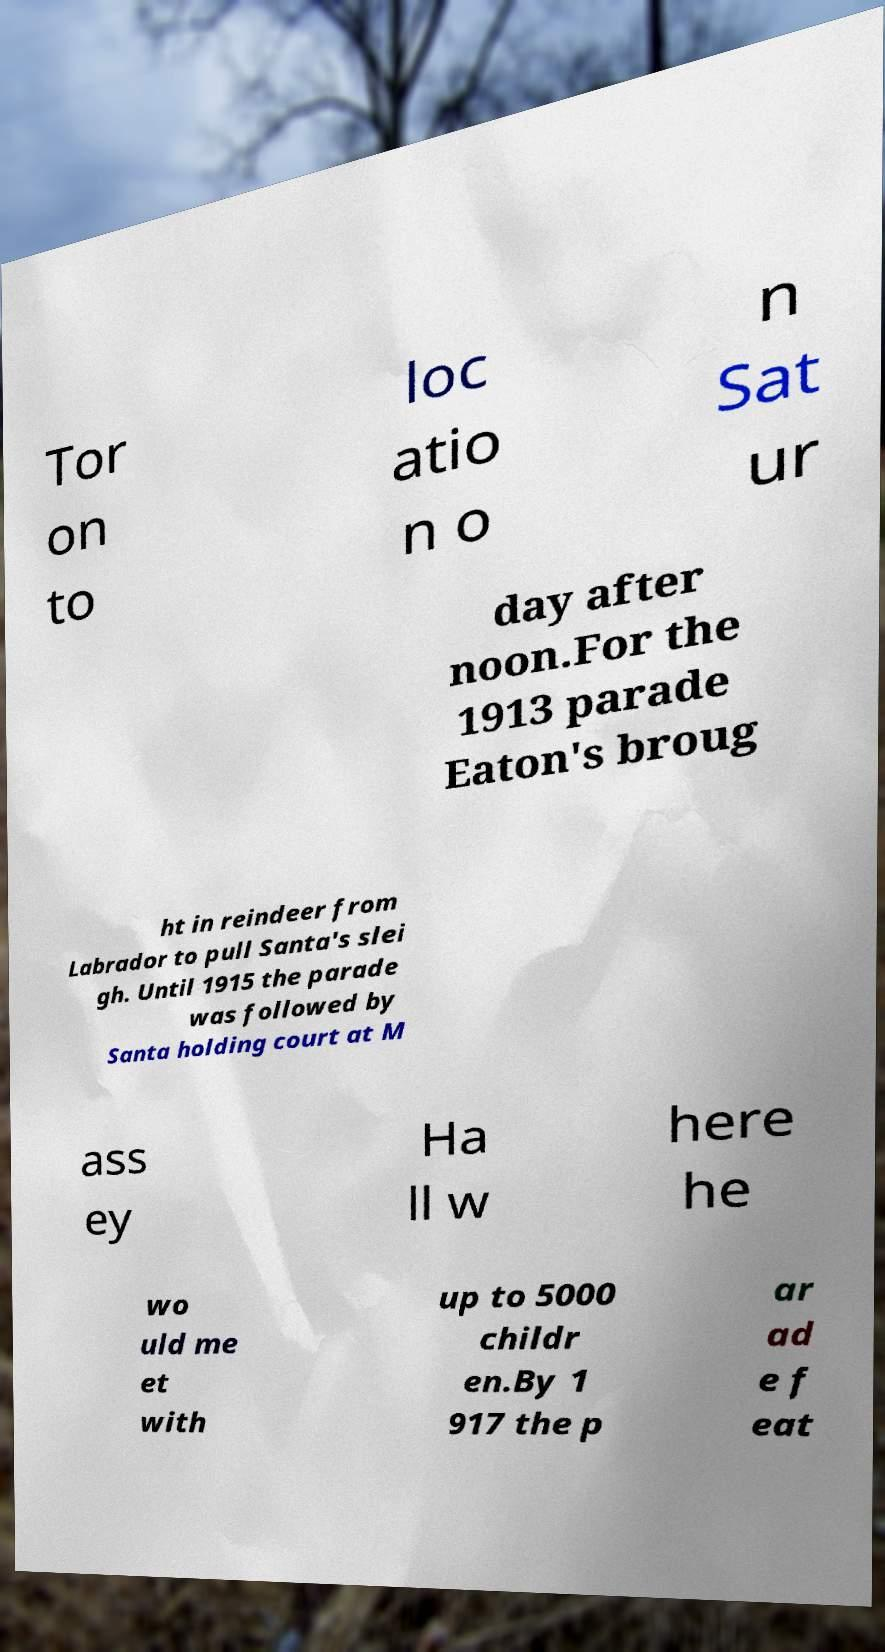Could you assist in decoding the text presented in this image and type it out clearly? Tor on to loc atio n o n Sat ur day after noon.For the 1913 parade Eaton's broug ht in reindeer from Labrador to pull Santa's slei gh. Until 1915 the parade was followed by Santa holding court at M ass ey Ha ll w here he wo uld me et with up to 5000 childr en.By 1 917 the p ar ad e f eat 